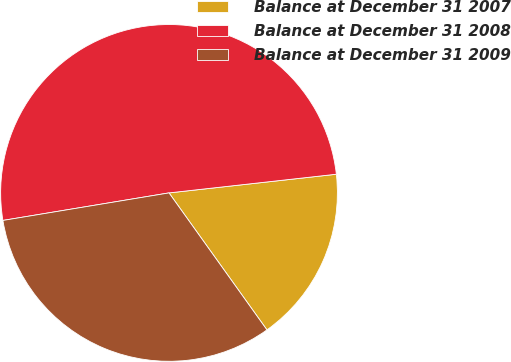Convert chart to OTSL. <chart><loc_0><loc_0><loc_500><loc_500><pie_chart><fcel>Balance at December 31 2007<fcel>Balance at December 31 2008<fcel>Balance at December 31 2009<nl><fcel>16.89%<fcel>50.84%<fcel>32.26%<nl></chart> 